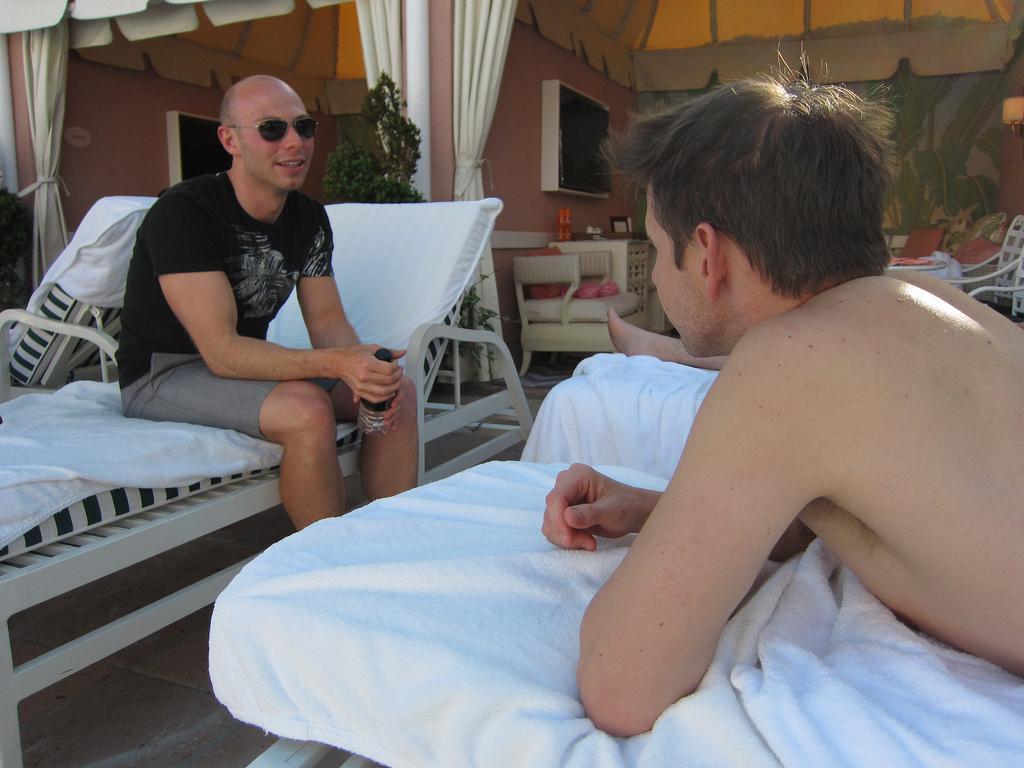Could you give a brief overview of what you see in this image? This picture a person sitting on bed is holding a bottle. He is google, black shirt and short. At the right side there is a person lying on the bed and backside of this bed there is a plant. Background of the image there is a chair and television mounted on wall. 